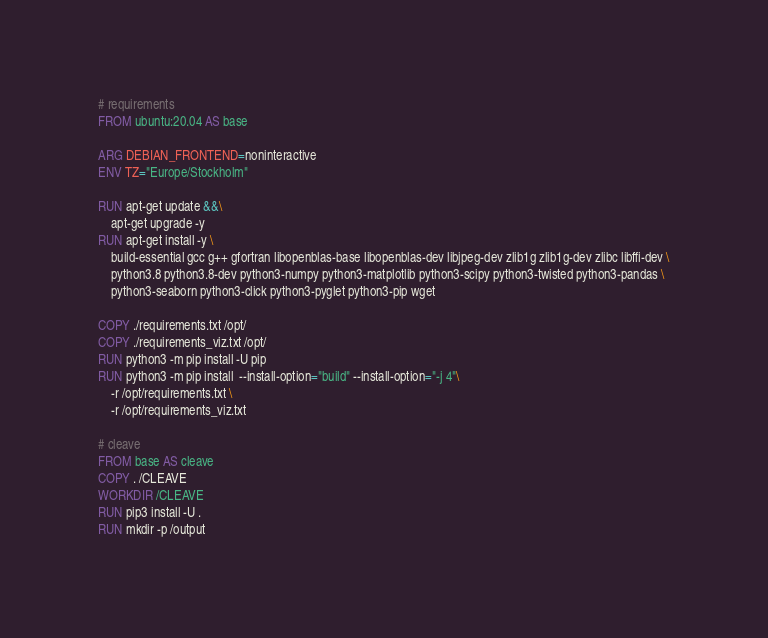<code> <loc_0><loc_0><loc_500><loc_500><_Dockerfile_># requirements
FROM ubuntu:20.04 AS base

ARG DEBIAN_FRONTEND=noninteractive
ENV TZ="Europe/Stockholm"

RUN apt-get update &&\
    apt-get upgrade -y
RUN apt-get install -y \
    build-essential gcc g++ gfortran libopenblas-base libopenblas-dev libjpeg-dev zlib1g zlib1g-dev zlibc libffi-dev \
    python3.8 python3.8-dev python3-numpy python3-matplotlib python3-scipy python3-twisted python3-pandas \
    python3-seaborn python3-click python3-pyglet python3-pip wget

COPY ./requirements.txt /opt/
COPY ./requirements_viz.txt /opt/
RUN python3 -m pip install -U pip
RUN python3 -m pip install  --install-option="build" --install-option="-j 4"\
    -r /opt/requirements.txt \
    -r /opt/requirements_viz.txt

# cleave
FROM base AS cleave
COPY . /CLEAVE
WORKDIR /CLEAVE
RUN pip3 install -U .
RUN mkdir -p /output
</code> 